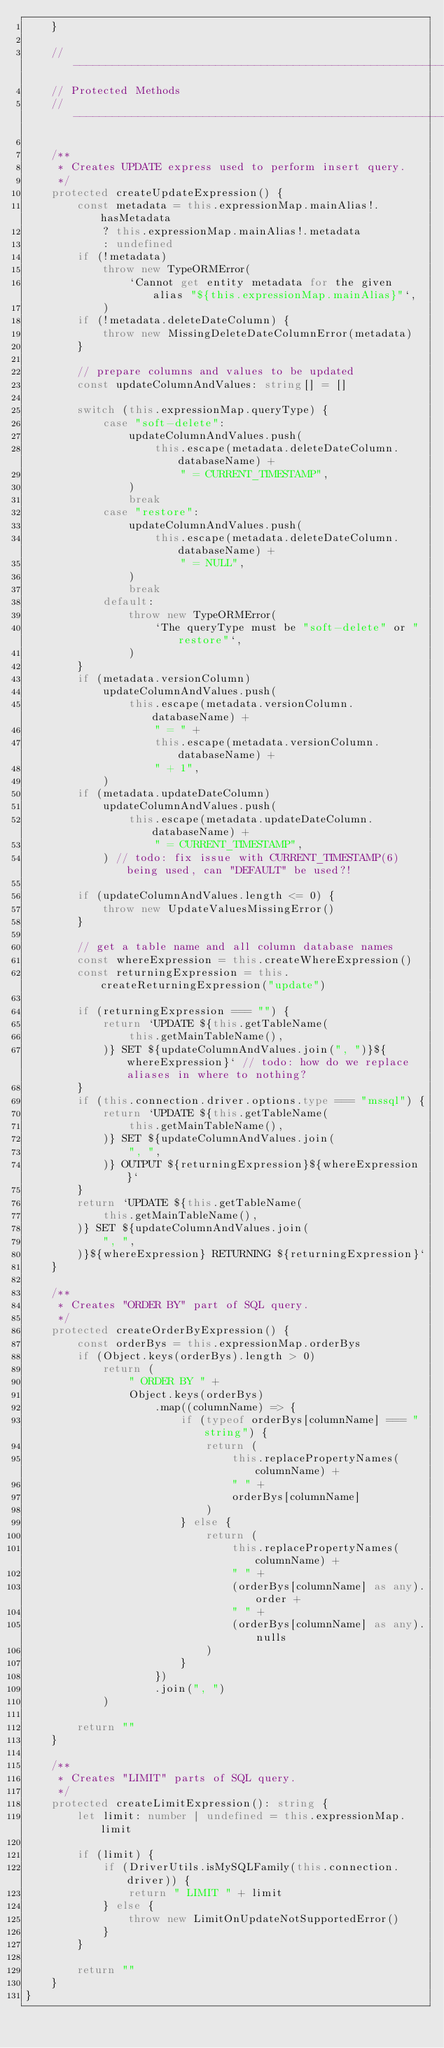Convert code to text. <code><loc_0><loc_0><loc_500><loc_500><_TypeScript_>    }

    // -------------------------------------------------------------------------
    // Protected Methods
    // -------------------------------------------------------------------------

    /**
     * Creates UPDATE express used to perform insert query.
     */
    protected createUpdateExpression() {
        const metadata = this.expressionMap.mainAlias!.hasMetadata
            ? this.expressionMap.mainAlias!.metadata
            : undefined
        if (!metadata)
            throw new TypeORMError(
                `Cannot get entity metadata for the given alias "${this.expressionMap.mainAlias}"`,
            )
        if (!metadata.deleteDateColumn) {
            throw new MissingDeleteDateColumnError(metadata)
        }

        // prepare columns and values to be updated
        const updateColumnAndValues: string[] = []

        switch (this.expressionMap.queryType) {
            case "soft-delete":
                updateColumnAndValues.push(
                    this.escape(metadata.deleteDateColumn.databaseName) +
                        " = CURRENT_TIMESTAMP",
                )
                break
            case "restore":
                updateColumnAndValues.push(
                    this.escape(metadata.deleteDateColumn.databaseName) +
                        " = NULL",
                )
                break
            default:
                throw new TypeORMError(
                    `The queryType must be "soft-delete" or "restore"`,
                )
        }
        if (metadata.versionColumn)
            updateColumnAndValues.push(
                this.escape(metadata.versionColumn.databaseName) +
                    " = " +
                    this.escape(metadata.versionColumn.databaseName) +
                    " + 1",
            )
        if (metadata.updateDateColumn)
            updateColumnAndValues.push(
                this.escape(metadata.updateDateColumn.databaseName) +
                    " = CURRENT_TIMESTAMP",
            ) // todo: fix issue with CURRENT_TIMESTAMP(6) being used, can "DEFAULT" be used?!

        if (updateColumnAndValues.length <= 0) {
            throw new UpdateValuesMissingError()
        }

        // get a table name and all column database names
        const whereExpression = this.createWhereExpression()
        const returningExpression = this.createReturningExpression("update")

        if (returningExpression === "") {
            return `UPDATE ${this.getTableName(
                this.getMainTableName(),
            )} SET ${updateColumnAndValues.join(", ")}${whereExpression}` // todo: how do we replace aliases in where to nothing?
        }
        if (this.connection.driver.options.type === "mssql") {
            return `UPDATE ${this.getTableName(
                this.getMainTableName(),
            )} SET ${updateColumnAndValues.join(
                ", ",
            )} OUTPUT ${returningExpression}${whereExpression}`
        }
        return `UPDATE ${this.getTableName(
            this.getMainTableName(),
        )} SET ${updateColumnAndValues.join(
            ", ",
        )}${whereExpression} RETURNING ${returningExpression}`
    }

    /**
     * Creates "ORDER BY" part of SQL query.
     */
    protected createOrderByExpression() {
        const orderBys = this.expressionMap.orderBys
        if (Object.keys(orderBys).length > 0)
            return (
                " ORDER BY " +
                Object.keys(orderBys)
                    .map((columnName) => {
                        if (typeof orderBys[columnName] === "string") {
                            return (
                                this.replacePropertyNames(columnName) +
                                " " +
                                orderBys[columnName]
                            )
                        } else {
                            return (
                                this.replacePropertyNames(columnName) +
                                " " +
                                (orderBys[columnName] as any).order +
                                " " +
                                (orderBys[columnName] as any).nulls
                            )
                        }
                    })
                    .join(", ")
            )

        return ""
    }

    /**
     * Creates "LIMIT" parts of SQL query.
     */
    protected createLimitExpression(): string {
        let limit: number | undefined = this.expressionMap.limit

        if (limit) {
            if (DriverUtils.isMySQLFamily(this.connection.driver)) {
                return " LIMIT " + limit
            } else {
                throw new LimitOnUpdateNotSupportedError()
            }
        }

        return ""
    }
}
</code> 